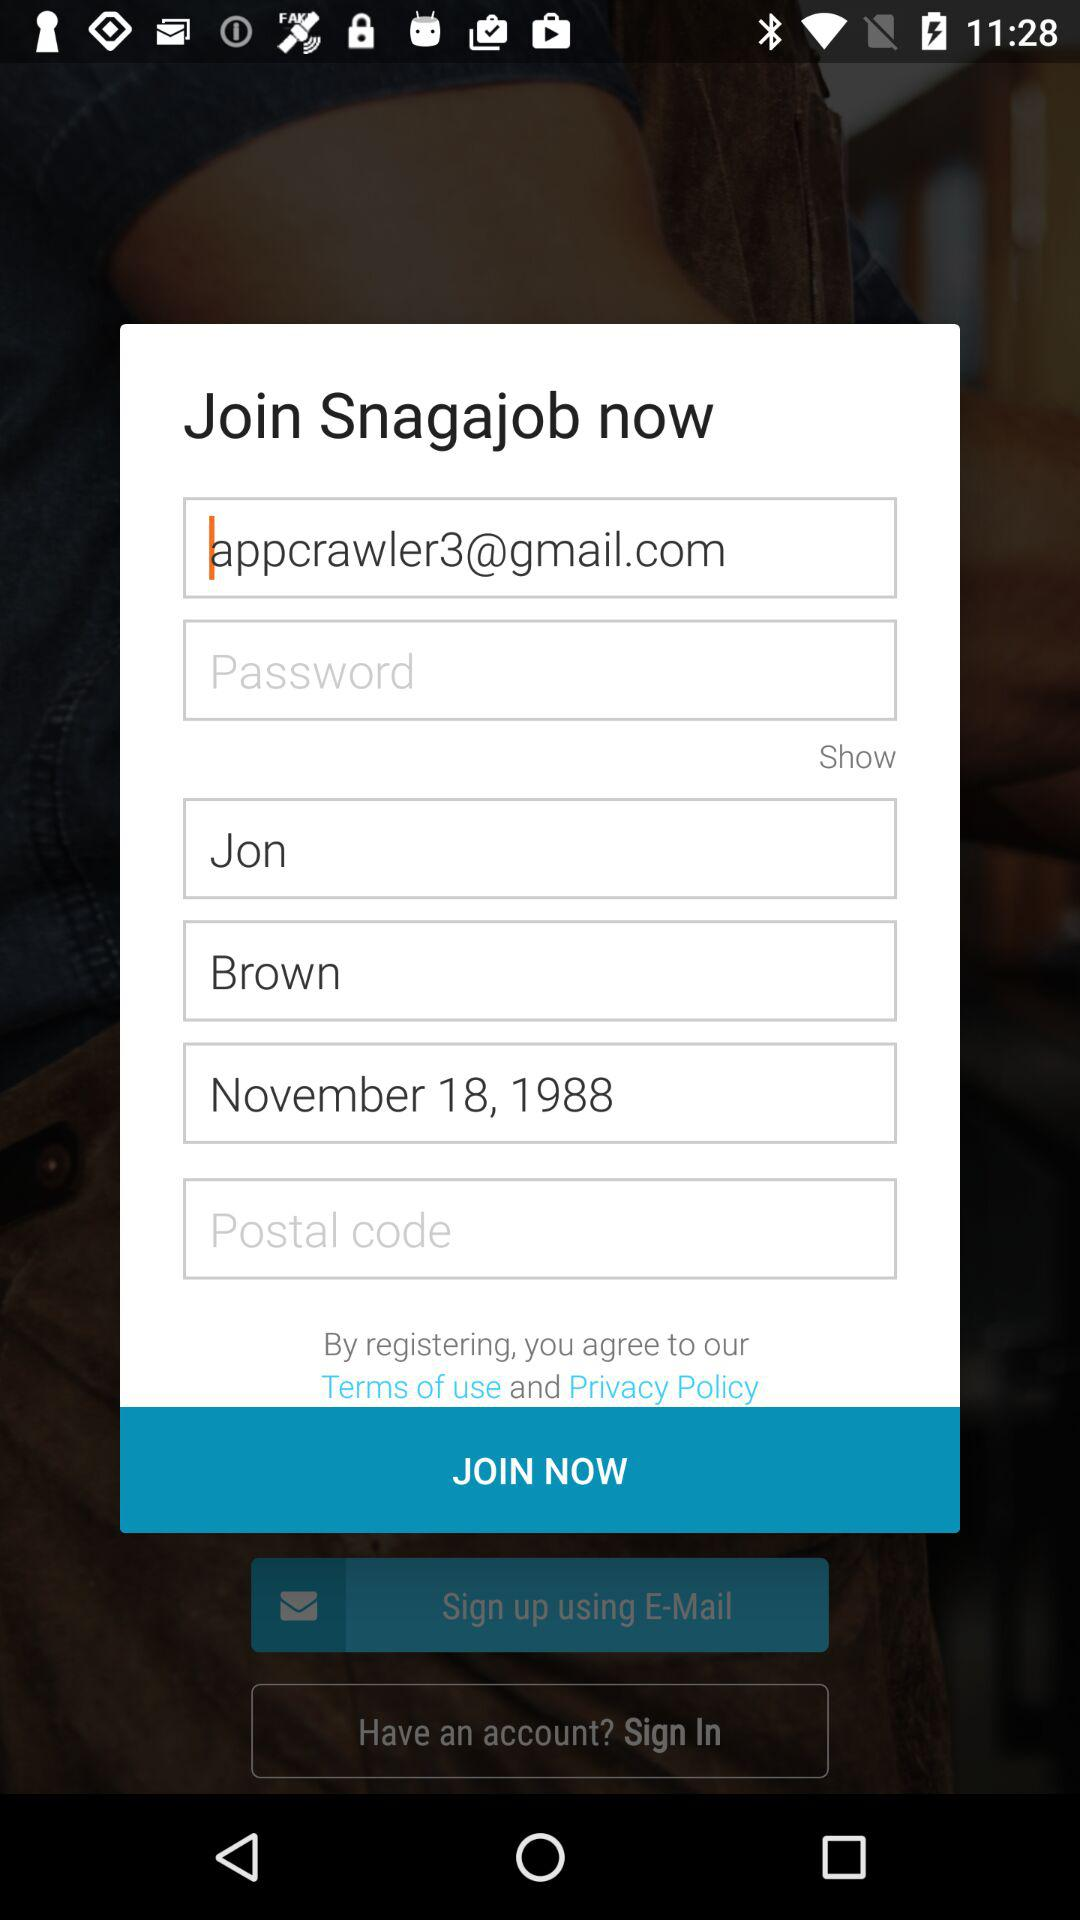What is the date of birth? The date of birth is November 18, 1988. 